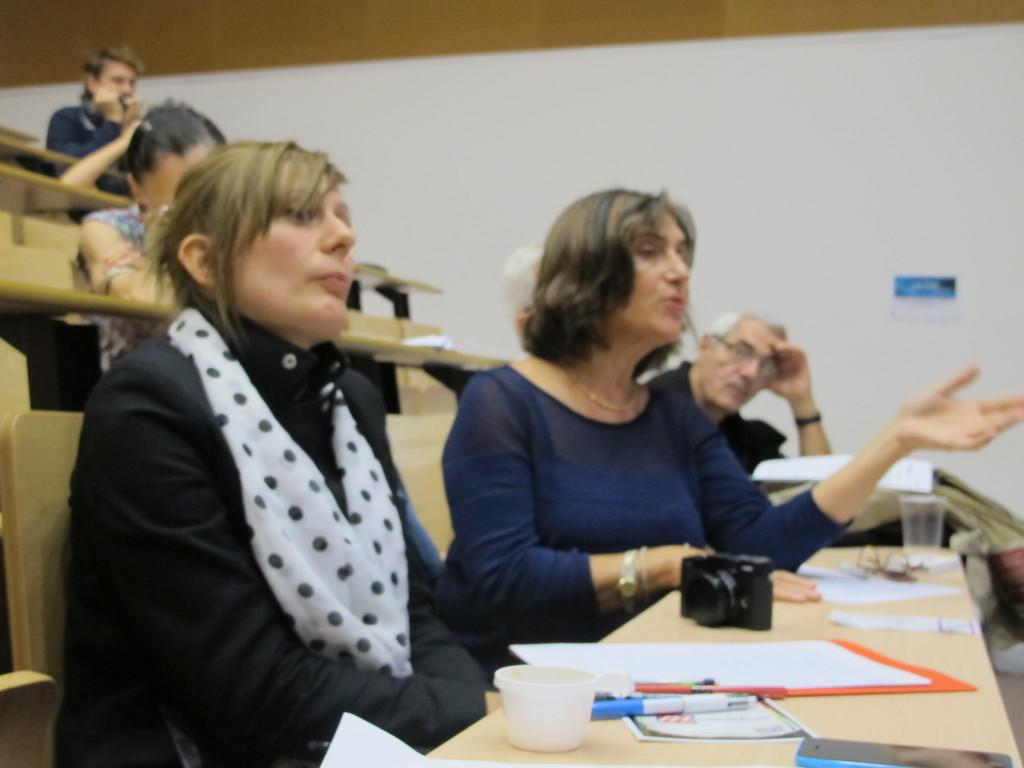How many persons are in the image? There is a group of persons in the image. What are the persons doing in the image? The persons are sitting on benches. What objects can be seen in the image related to writing or drawing? There are pens in the image. What device is used for capturing images in the image? There is a camera in the image. What items are on the table in the image? There are papers on the top of a table in the image. Where is the table located in the image? The table is located on the right side of the image. What religious discovery is being made by the persons in the image? There is no indication of a religious discovery in the image; the persons are simply sitting on benches. 